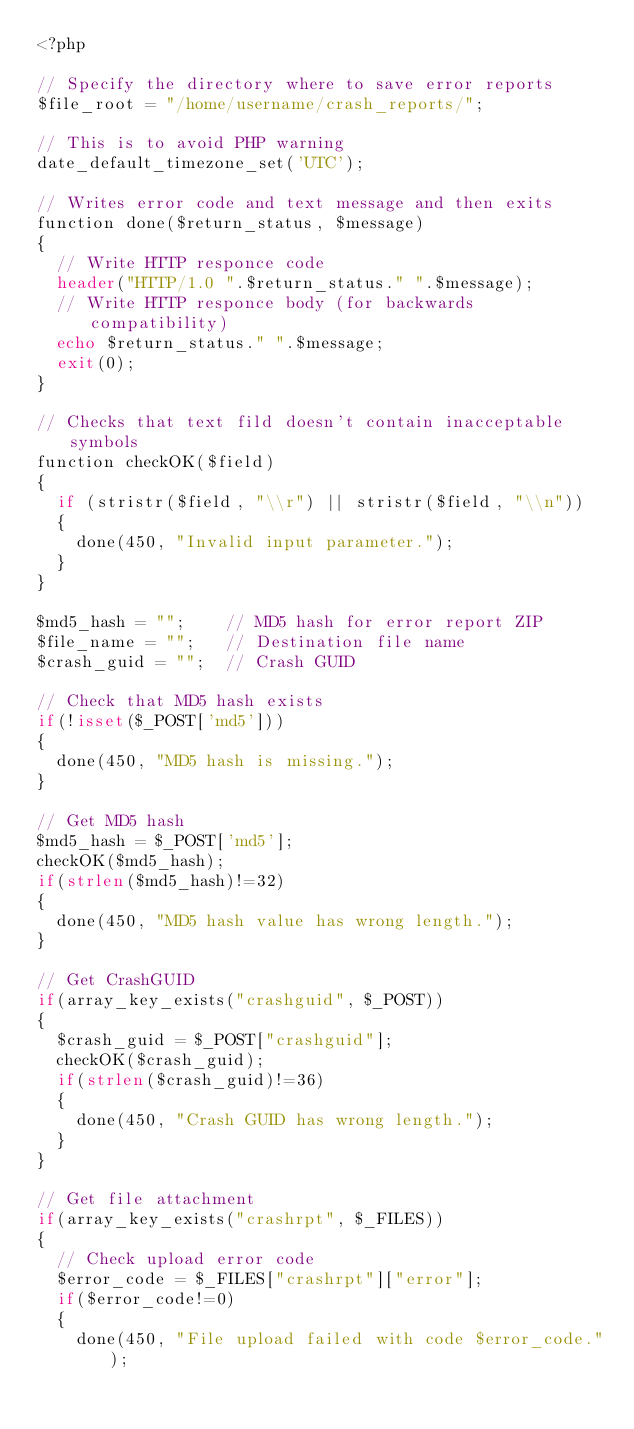<code> <loc_0><loc_0><loc_500><loc_500><_PHP_><?php

// Specify the directory where to save error reports
$file_root = "/home/username/crash_reports/";

// This is to avoid PHP warning
date_default_timezone_set('UTC');

// Writes error code and text message and then exits
function done($return_status, $message)
{
  // Write HTTP responce code
  header("HTTP/1.0 ".$return_status." ".$message);
  // Write HTTP responce body (for backwards compatibility)
  echo $return_status." ".$message; 
  exit(0);
}

// Checks that text fild doesn't contain inacceptable symbols
function checkOK($field)
{
  if (stristr($field, "\\r") || stristr($field, "\\n")) 
  {
    done(450, "Invalid input parameter.");
  }
}

$md5_hash = "";    // MD5 hash for error report ZIP
$file_name = "";   // Destination file name                                  
$crash_guid = "";  // Crash GUID

// Check that MD5 hash exists 
if(!isset($_POST['md5']))
{
  done(450, "MD5 hash is missing.");
}

// Get MD5 hash
$md5_hash = $_POST['md5'];
checkOK($md5_hash);
if(strlen($md5_hash)!=32)
{
  done(450, "MD5 hash value has wrong length.");
}

// Get CrashGUID
if(array_key_exists("crashguid", $_POST))
{
  $crash_guid = $_POST["crashguid"];
  checkOK($crash_guid);
  if(strlen($crash_guid)!=36)
  {
    done(450, "Crash GUID has wrong length.");
  }  
}

// Get file attachment
if(array_key_exists("crashrpt", $_FILES))
{
  // Check upload error code
  $error_code = $_FILES["crashrpt"]["error"];
  if($error_code!=0)
  {
    done(450, "File upload failed with code $error_code.");</code> 